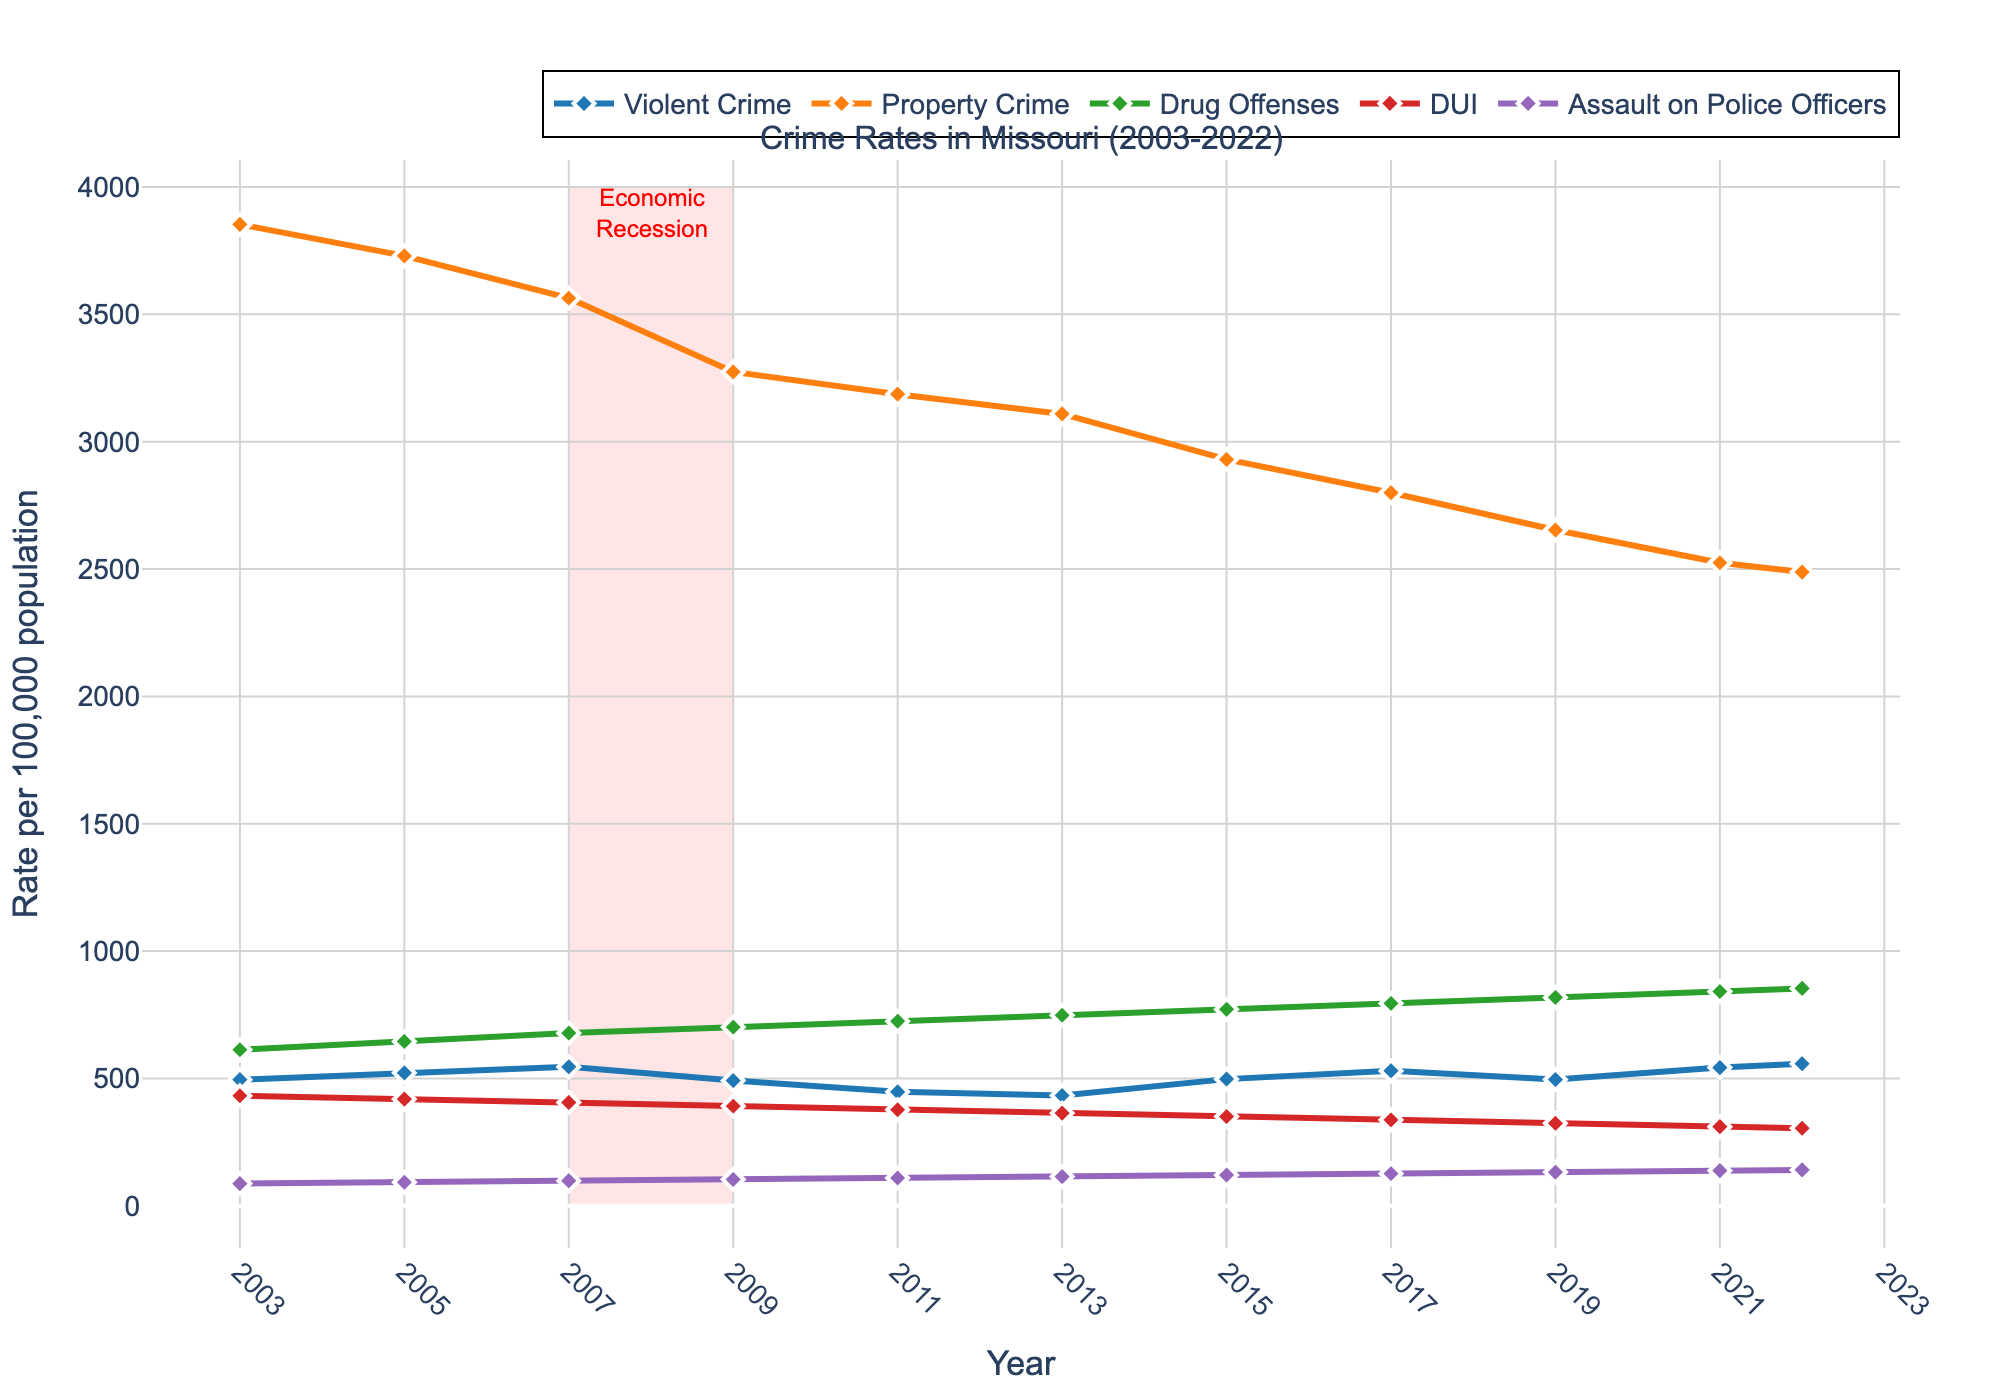What is the overall trend of violent crimes from 2003 to 2022? The rate appears to generally increase, with peaks and troughs over the years. Starting at 495.3 in 2003, there are increases and decreases, eventually reaching 557.9 in 2022, indicating a rising trend.
Answer: Rising trend Between 2003 and 2022, during which years does the property crime rate fall below 3000? To find this, check the years where the property crime rate is less than 3000. The years are 2015, 2017, 2019, 2021, and 2022.
Answer: 2015, 2017, 2019, 2021, 2022 What visual element is used to highlight the years 2007 to 2009 and what does it signify? A translucent red rectangle encompasses the years 2007 to 2009, signifying an important period, annotated as the "Economic Recession".
Answer: Red rectangle, Economic Recession Which category displays the highest increase in rate from 2003 to 2022? To identify the category, compare the rate differences (2022 rate - 2003 rate) for each offense type: Violent Crime (62.6), Property Crime (-1365.1), Drug Offenses (240.8), DUI (-127.6), Assault on Police Officers (53.8). Drug Offenses show the highest increase (240.8).
Answer: Drug Offenses Compare the rate of Assault on Police Officers to Violent Crimes in 2022. Which is higher? In 2022, the rate of Violent Crimes is 557.9, whereas Assault on Police Officers is 141. The rate of Violent Crimes is therefore higher.
Answer: Violent Crimes During which period does the rate of Drug Offenses increase the most? Observing the increments between years shows that the largest increase occurred between 2011 (724.8) and 2022 (853.5), an increase of 128.7.
Answer: 2011-2022 Calculate the average rate of Property Crimes for the years 2003, 2005, and 2007. Sum the Property Crimes (2003: 3853.2, 2005: 3729.5, 2007: 3563.8) and divide by 3. (3853.2 + 3729.5 + 3563.8) / 3 = 3715.5
Answer: 3715.5 How does the rate of DUI change from 2003 to 2022? Comparing the rate of DUI in 2003 (432.1) to that in 2022 (304.5), there is a decrease. The change is 432.1 - 304.5 = 127.6.
Answer: Decrease by 127.6 Which crime type had the lowest rate in 2003, and what was its value? The lowest rate in 2003 was Assault on Police Officers with a rate of 87.2.
Answer: Assault on Police Officers, 87.2 How does the trend for Property Crimes between 2003 and 2022 visually compare to the trend for Violent Crimes? The Property Crimes show a declining trend while Violent Crimes display a generally rising trend over the same period.
Answer: Declining vs Rising 